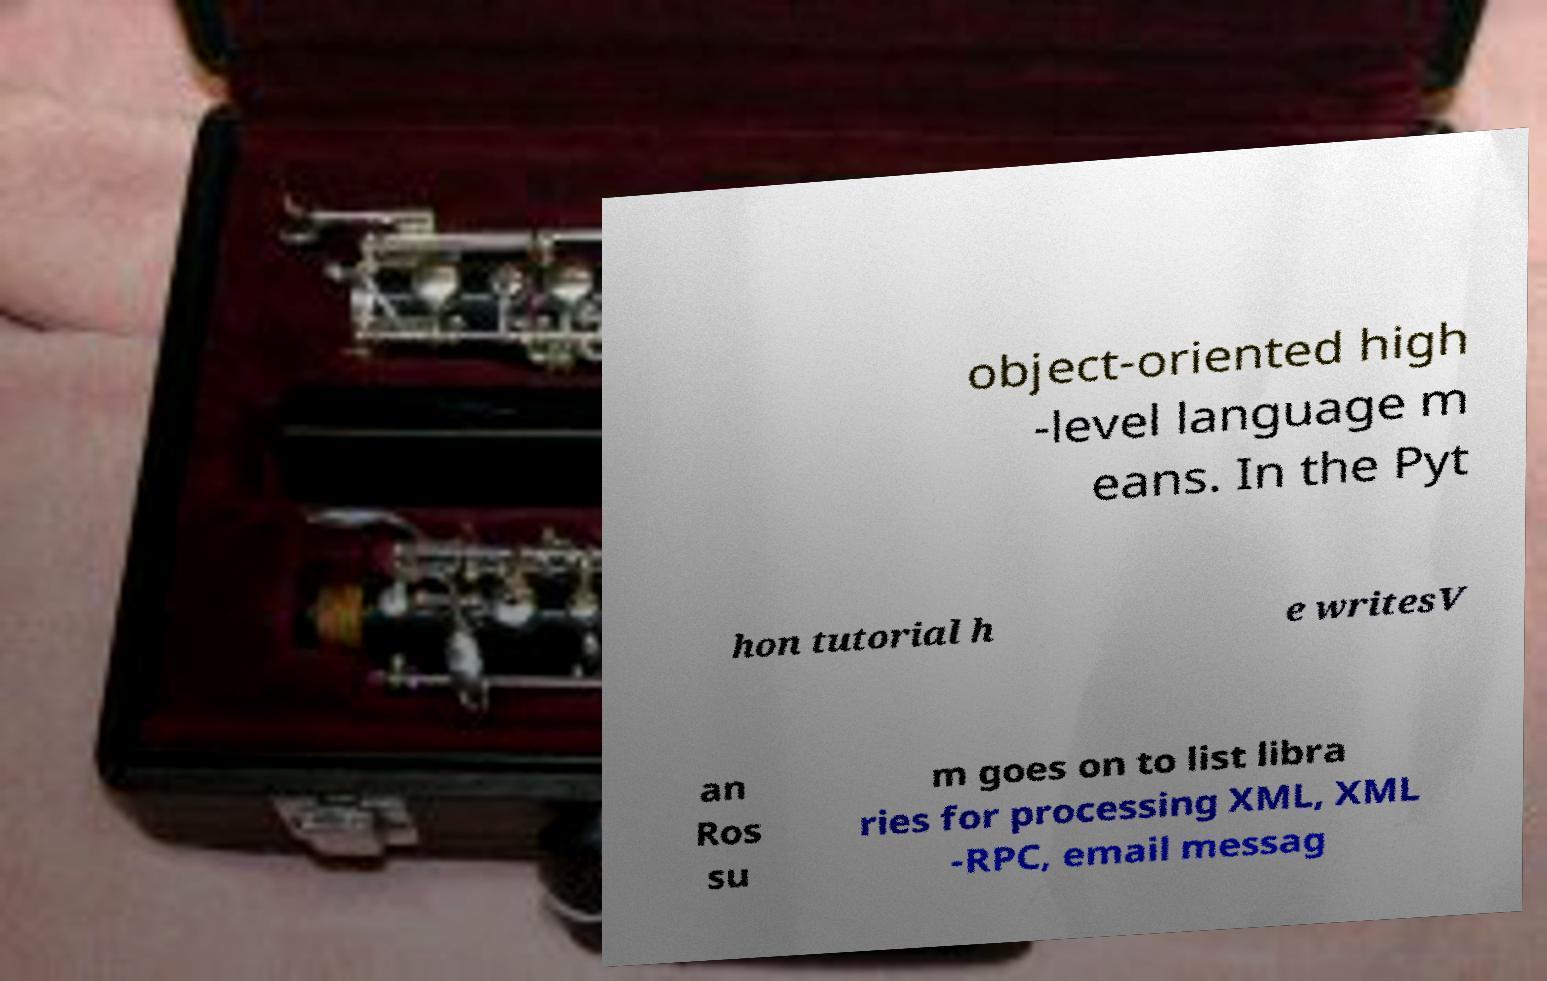Could you assist in decoding the text presented in this image and type it out clearly? object-oriented high -level language m eans. In the Pyt hon tutorial h e writesV an Ros su m goes on to list libra ries for processing XML, XML -RPC, email messag 